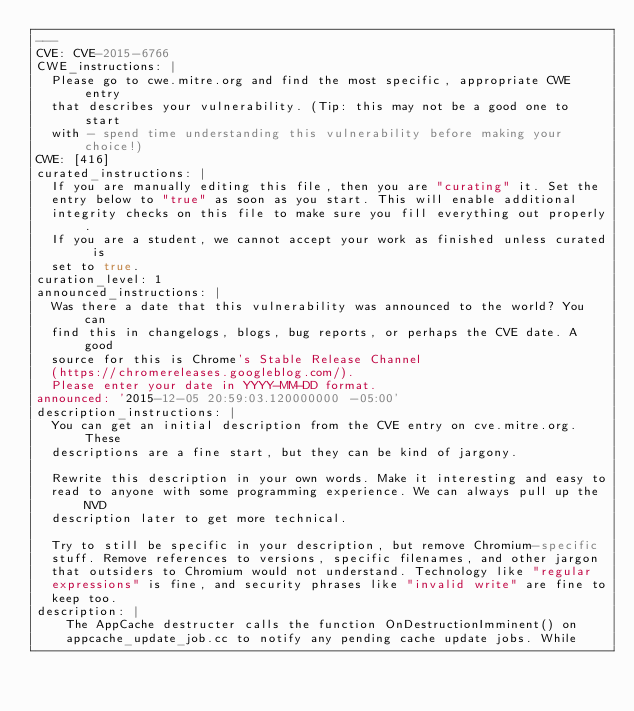<code> <loc_0><loc_0><loc_500><loc_500><_YAML_>---
CVE: CVE-2015-6766
CWE_instructions: |
  Please go to cwe.mitre.org and find the most specific, appropriate CWE entry
  that describes your vulnerability. (Tip: this may not be a good one to start
  with - spend time understanding this vulnerability before making your choice!)
CWE: [416]
curated_instructions: |
  If you are manually editing this file, then you are "curating" it. Set the
  entry below to "true" as soon as you start. This will enable additional
  integrity checks on this file to make sure you fill everything out properly.
  If you are a student, we cannot accept your work as finished unless curated is
  set to true.
curation_level: 1
announced_instructions: |
  Was there a date that this vulnerability was announced to the world? You can
  find this in changelogs, blogs, bug reports, or perhaps the CVE date. A good
  source for this is Chrome's Stable Release Channel
  (https://chromereleases.googleblog.com/).
  Please enter your date in YYYY-MM-DD format.
announced: '2015-12-05 20:59:03.120000000 -05:00'
description_instructions: |
  You can get an initial description from the CVE entry on cve.mitre.org. These
  descriptions are a fine start, but they can be kind of jargony.

  Rewrite this description in your own words. Make it interesting and easy to
  read to anyone with some programming experience. We can always pull up the NVD
  description later to get more technical.

  Try to still be specific in your description, but remove Chromium-specific
  stuff. Remove references to versions, specific filenames, and other jargon
  that outsiders to Chromium would not understand. Technology like "regular
  expressions" is fine, and security phrases like "invalid write" are fine to
  keep too.
description: |
    The AppCache destructer calls the function OnDestructionImminent() on 
    appcache_update_job.cc to notify any pending cache update jobs. While </code> 